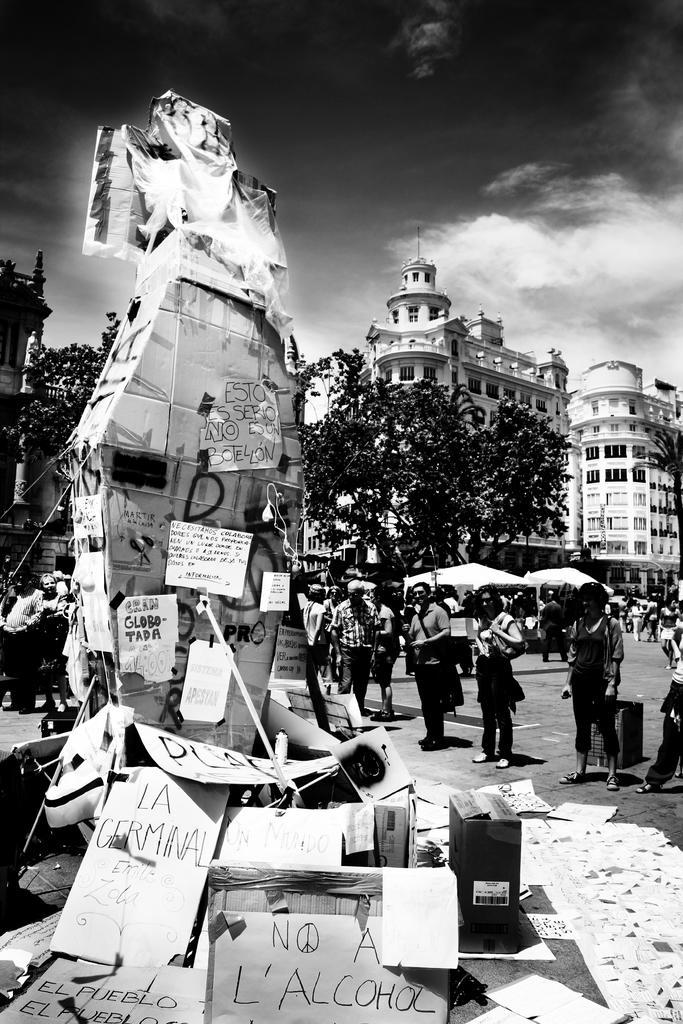Describe this image in one or two sentences. In this image there is a statue having few posts attached to it. Bottom of the image there are few boards and posters. Few people are on the road. Behind them there are tents. There are few trees. Behind there are few buildings. Top of the image there is sky. 